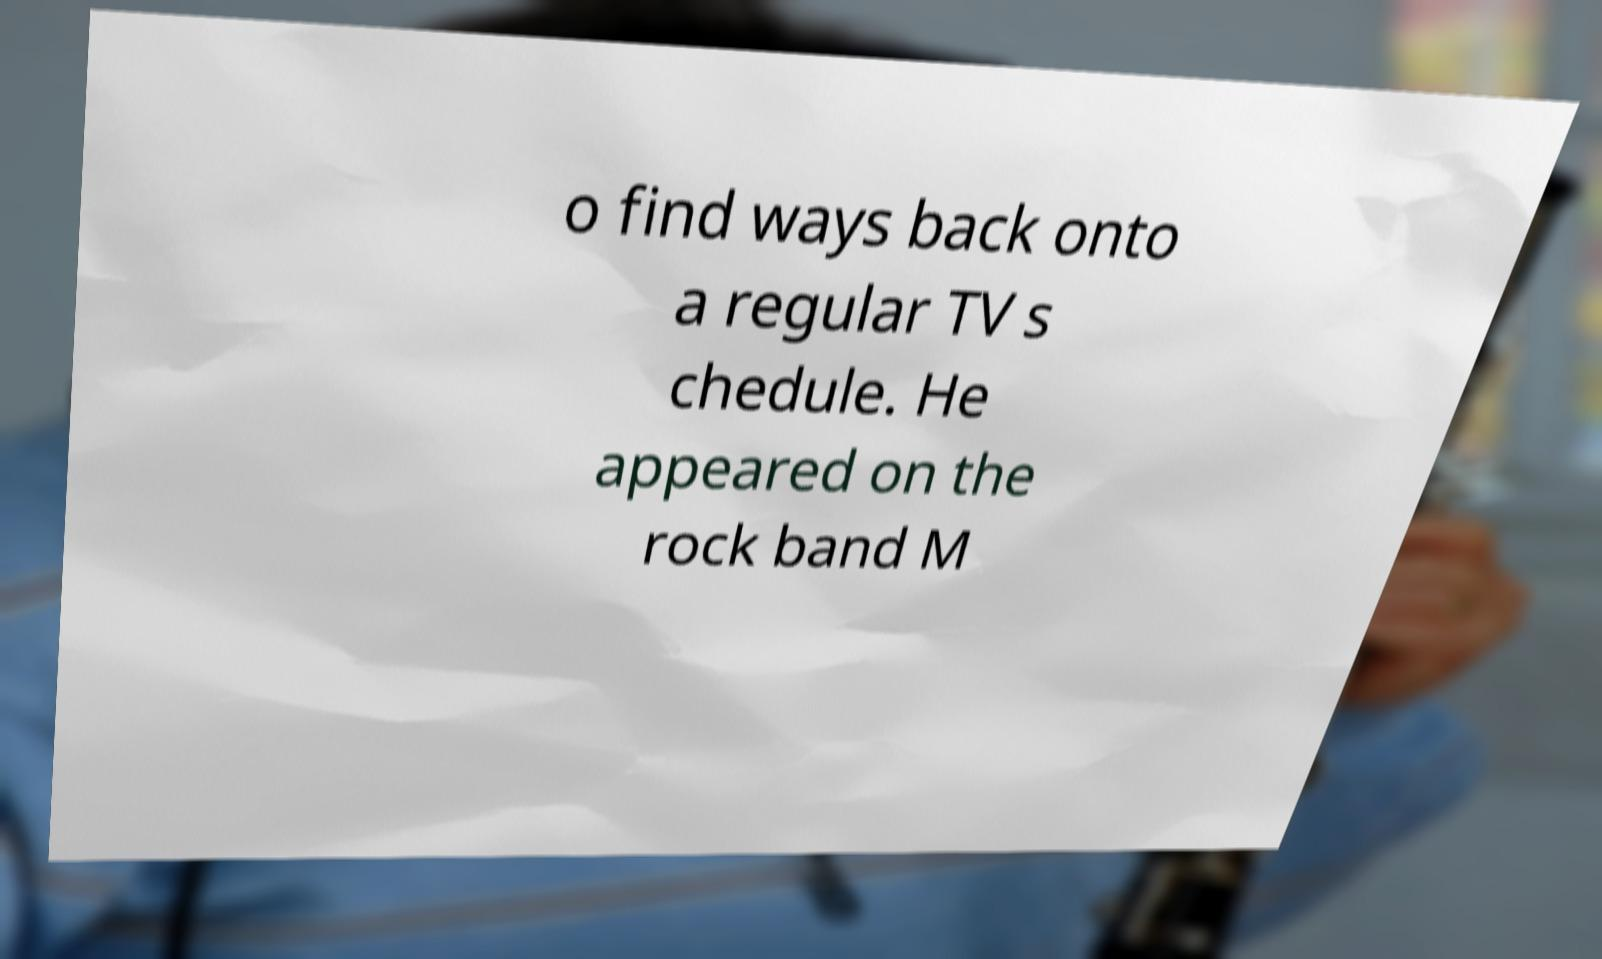I need the written content from this picture converted into text. Can you do that? o find ways back onto a regular TV s chedule. He appeared on the rock band M 